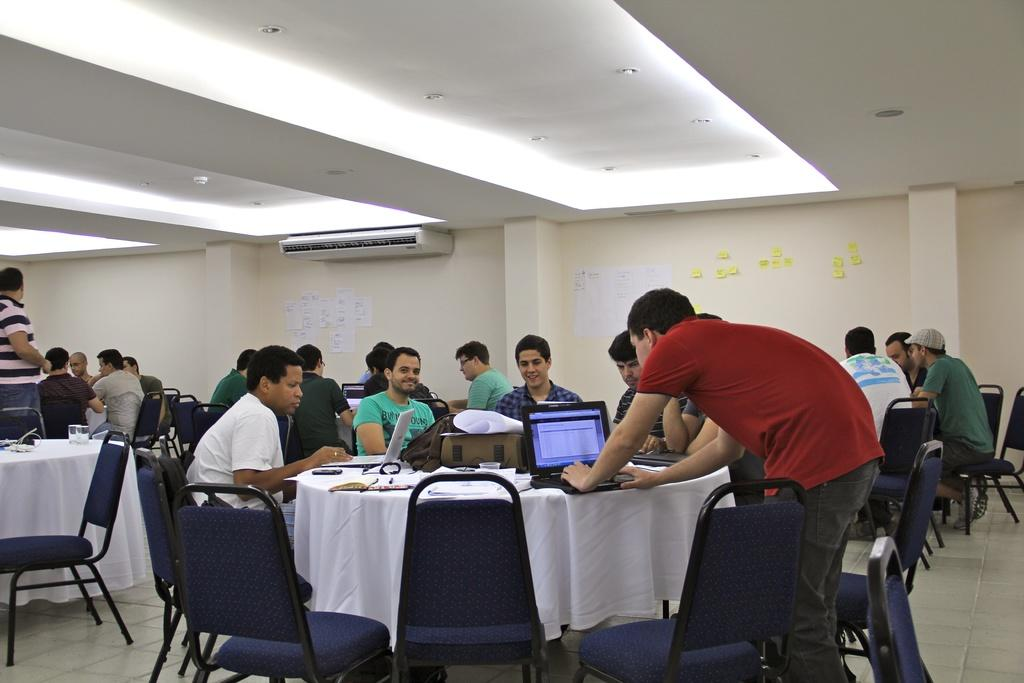Who or what is present in the image? There are people in the image. What type of furniture is visible in the image? There are chairs and tables in the image. Can you describe the background of the image? There are sticky notes on a wall in the background of the image. How many cacti are present on the tables in the image? There are no cacti present in the image; only people, chairs, tables, and sticky notes are visible. What type of utensil is being used by the pigs in the image? There are no pigs present in the image, so it is not possible to determine what utensil they might be using. 